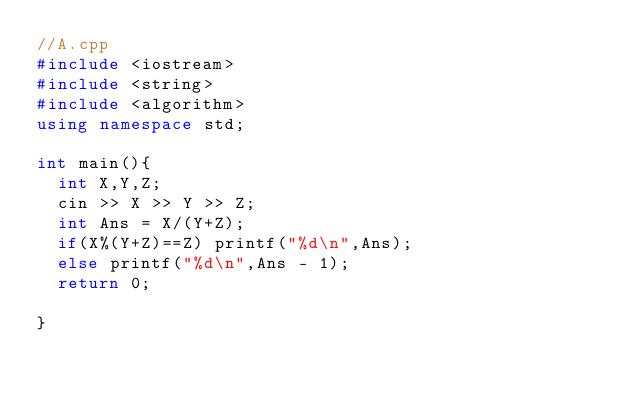<code> <loc_0><loc_0><loc_500><loc_500><_C++_>//A.cpp
#include <iostream>
#include <string>
#include <algorithm>
using namespace std;

int main(){
  int X,Y,Z;
  cin >> X >> Y >> Z;
  int Ans = X/(Y+Z);
  if(X%(Y+Z)==Z) printf("%d\n",Ans);
  else printf("%d\n",Ans - 1);
  return 0;

}
</code> 